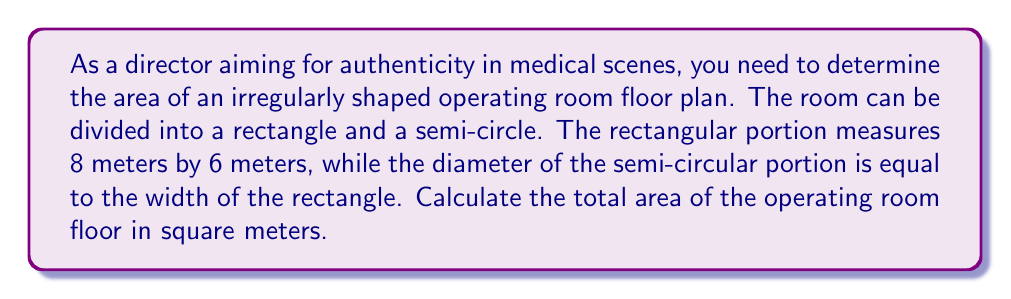Show me your answer to this math problem. Let's approach this step-by-step:

1) First, let's visualize the floor plan:

[asy]
unitsize(1cm);
path rectangle = box((0,0), (8,6));
path semicircle = arc((4,6), 3, 0, 180);
draw(rectangle);
draw(semicircle);
label("8m", (4,0), S);
label("6m", (0,3), W);
label("3m", (4,6), N);
[/asy]

2) The area of the operating room is the sum of the rectangular area and the semi-circular area.

3) Calculate the area of the rectangle:
   $A_{rectangle} = length \times width = 8 \times 6 = 48$ m²

4) For the semi-circle:
   - The diameter is equal to the width of the rectangle, which is 6m.
   - Therefore, the radius is 3m.

5) Calculate the area of the semi-circle:
   $A_{semicircle} = \frac{1}{2} \times \pi r^2 = \frac{1}{2} \times \pi \times 3^2 = \frac{9\pi}{2}$ m²

6) Total area:
   $$A_{total} = A_{rectangle} + A_{semicircle} = 48 + \frac{9\pi}{2}$$ m²

7) If we need a numerical value, we can approximate $\pi$ to 3.14159:
   $A_{total} \approx 48 + 14.13 = 62.13$ m²
Answer: $48 + \frac{9\pi}{2}$ m² (or approximately 62.13 m²) 